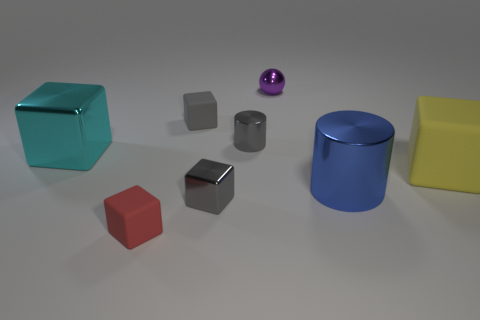Describe the arrangement of shapes on the table in terms of their proximity to each other. You'll notice an intriguing layout: a vibrant teal cube sits apart towards the left, while a red cube and a small gray block are close together in the foreground. Behind them, there's a tiny, shiny, metallic block with a purple sphere in the background. To the right, a large blue cylinder and a yellow rectangular prism are spaced apart, giving a sense of organized diversity among the shapes. 